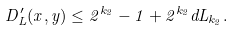Convert formula to latex. <formula><loc_0><loc_0><loc_500><loc_500>D ^ { \prime } _ { L } ( x , y ) \leq 2 ^ { k _ { 2 } } - 1 + 2 ^ { k _ { 2 } } d L _ { k _ { 2 } } .</formula> 